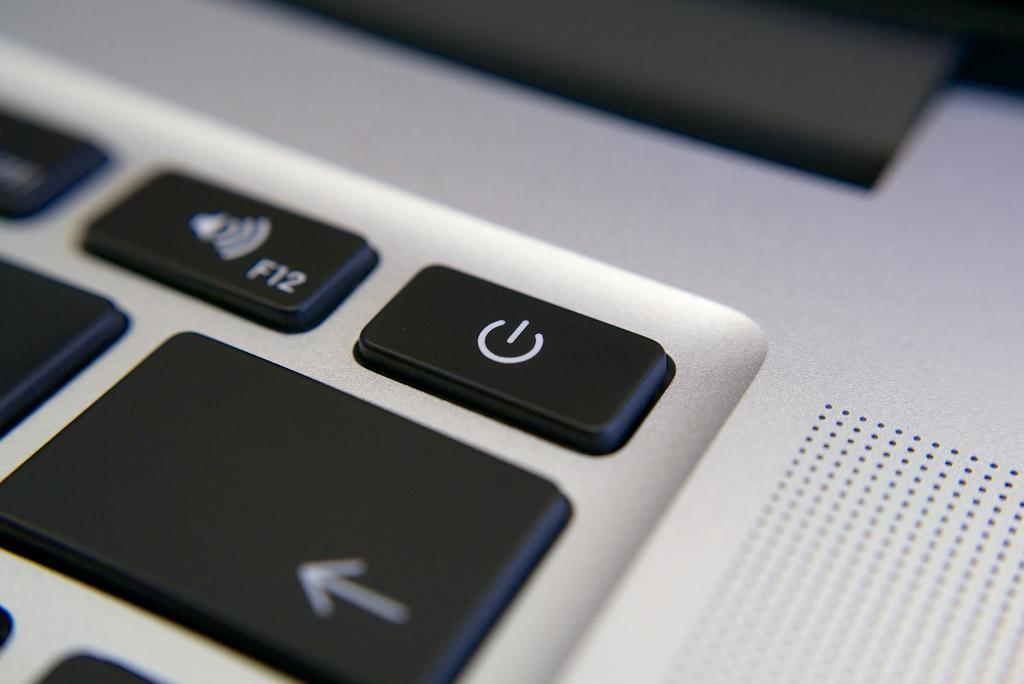<image>
Relay a brief, clear account of the picture shown. A close up of a laptop keyboardfocussing on the on , f12 and left arrow buttons. 